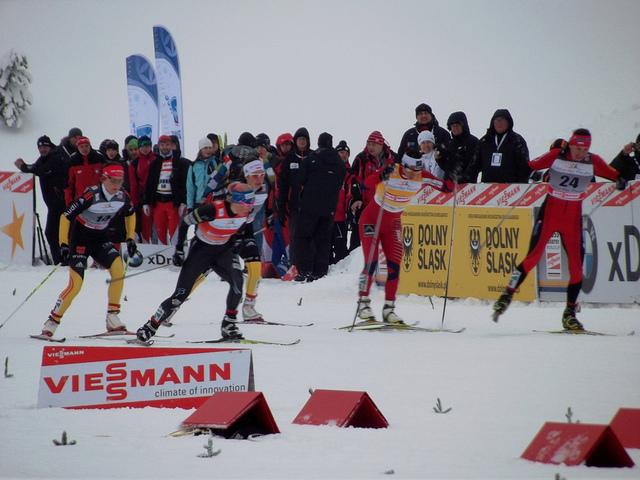Is the sign written in English?
Answer briefly. No. What color is the brightest color jacket?
Give a very brief answer. Red. Is it warm here?
Answer briefly. No. What sport is this?
Short answer required. Skiing. Will they be skiing?
Answer briefly. Yes. What is on the ground?
Concise answer only. Snow. What is written on the red sign?
Concise answer only. Viessmann. What are the orange things?
Be succinct. Signs. What items are being used as obstacles?
Give a very brief answer. Cones. Is any skier smiling?
Concise answer only. No. Is there a website listed?
Write a very short answer. No. What are they wearing on their feet?
Keep it brief. Skis. What is the wording on the barricades?
Answer briefly. Viessmann. What are the people holding?
Short answer required. Ski poles. Is the mans skis touching snow?
Concise answer only. Yes. 